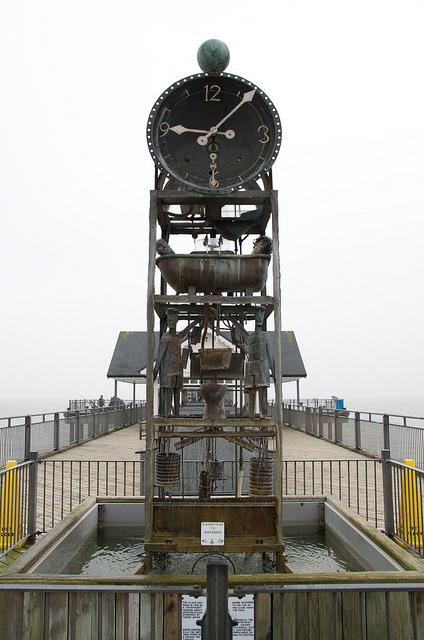Is the clock over water?
Short answer required. Yes. What time is on the clock?
Answer briefly. 9:06. What time does the clock say?
Keep it brief. 9:06. Where is this picture taken?
Answer briefly. Pier. 